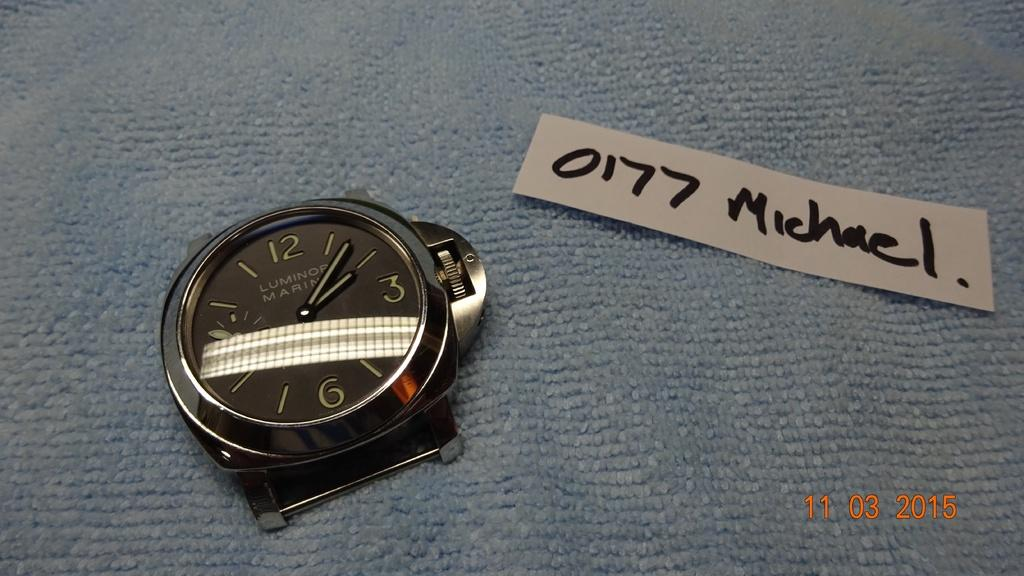<image>
Give a short and clear explanation of the subsequent image. Face of a watch with a piece of paper which says Michael on it. 